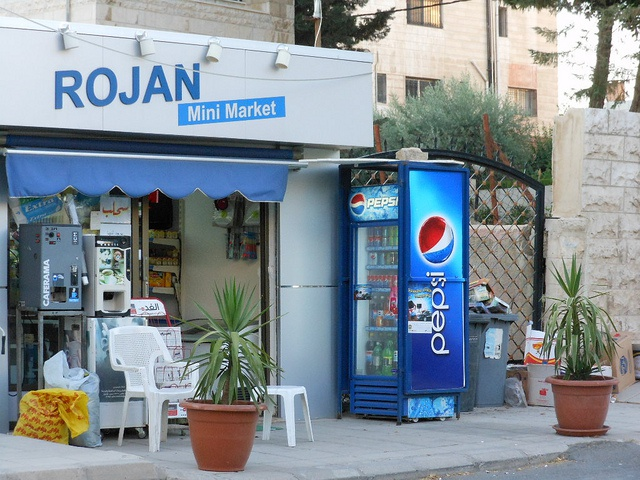Describe the objects in this image and their specific colors. I can see refrigerator in white, blue, navy, gray, and darkblue tones, potted plant in lightgray, gray, and maroon tones, potted plant in white, gray, darkgray, maroon, and black tones, chair in lightgray and darkgray tones, and bottle in white, gray, black, and darkgreen tones in this image. 